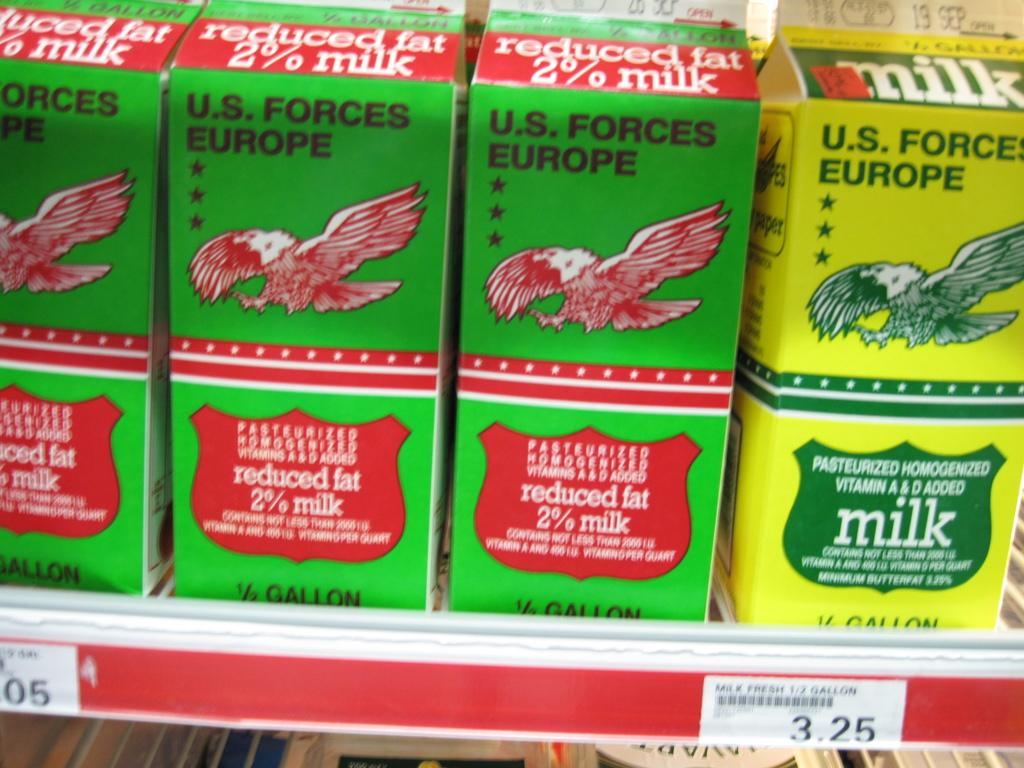What can be seen in the image that is used for storage? There is a shelf in the image that is used for storage. What is placed on the shelf? There are boxes on the shelf. What information is provided on the boxes? The boxes are labelled "US LABELLED FORCES." What shape is the farmer's hat in the image? There is no farmer or hat present in the image. 